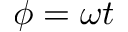<formula> <loc_0><loc_0><loc_500><loc_500>\phi = \omega t</formula> 